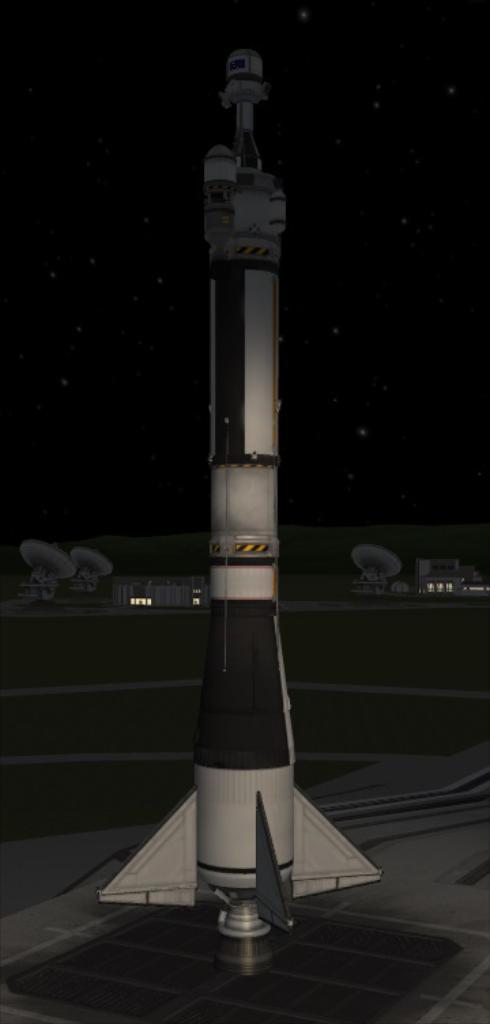Could you give a brief overview of what you see in this image? In this image I can see the digital art of a rocket which is white and black in color and in the background I can see few antennas, few buildings and the dark sky. 